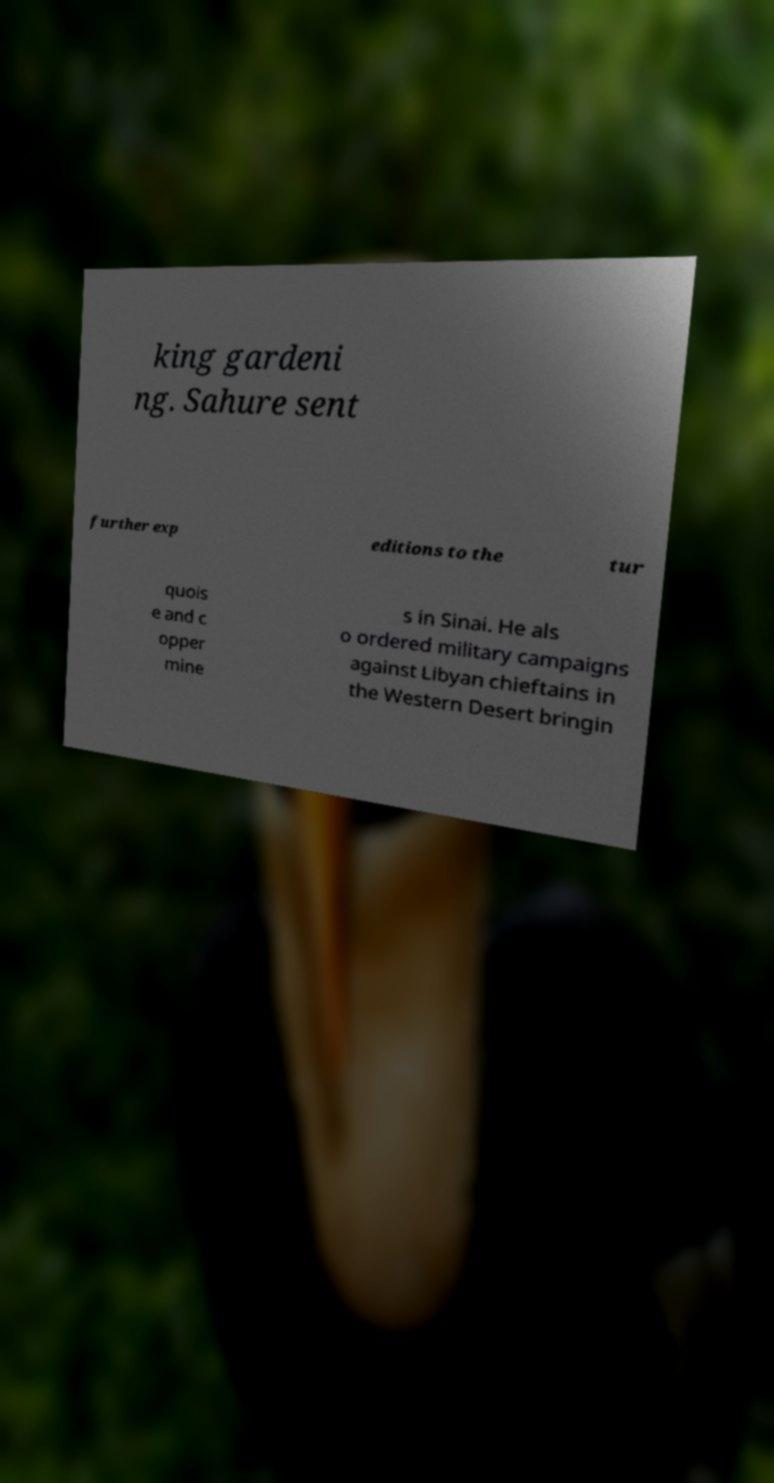Could you extract and type out the text from this image? king gardeni ng. Sahure sent further exp editions to the tur quois e and c opper mine s in Sinai. He als o ordered military campaigns against Libyan chieftains in the Western Desert bringin 